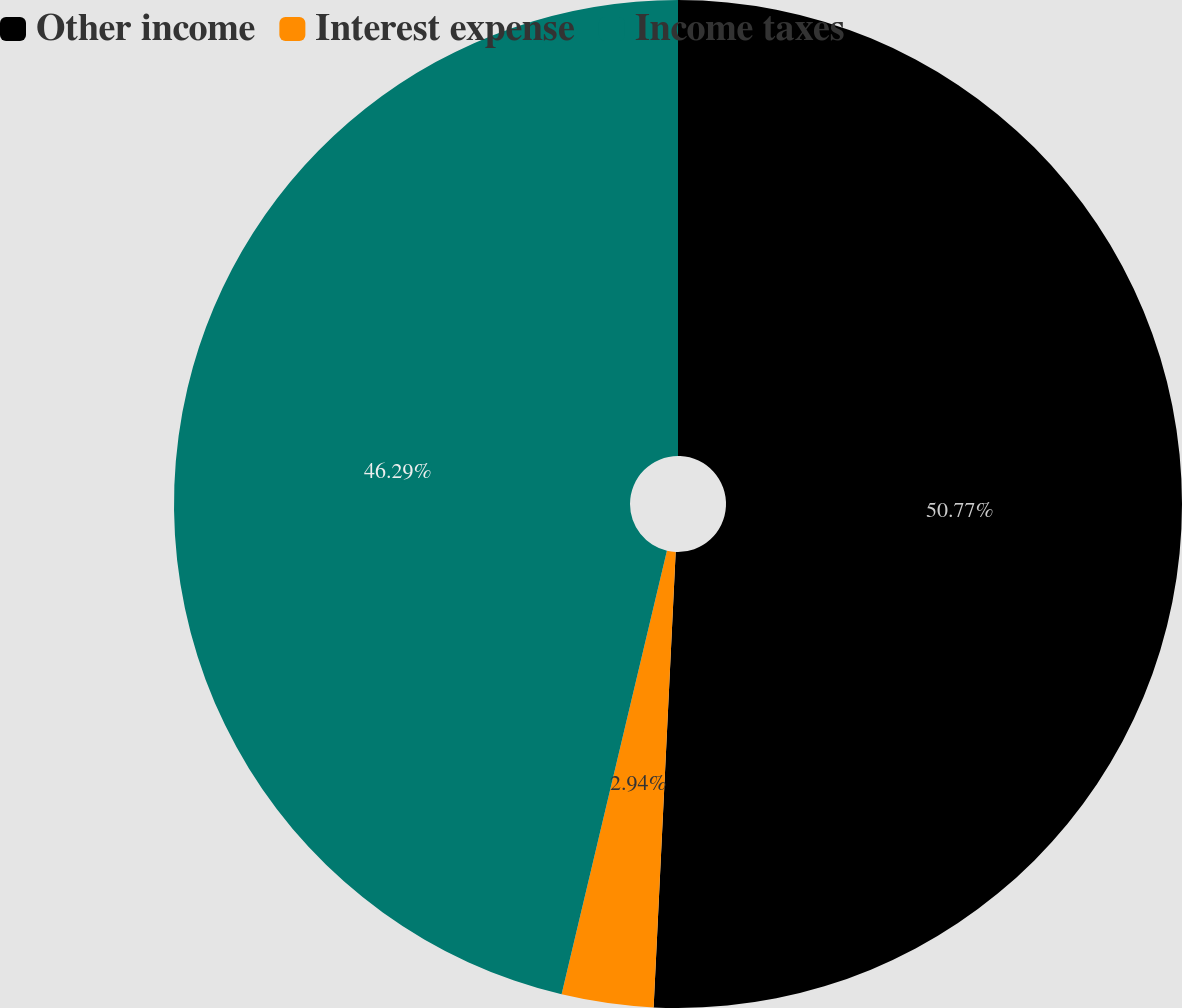<chart> <loc_0><loc_0><loc_500><loc_500><pie_chart><fcel>Other income<fcel>Interest expense<fcel>Income taxes<nl><fcel>50.77%<fcel>2.94%<fcel>46.29%<nl></chart> 